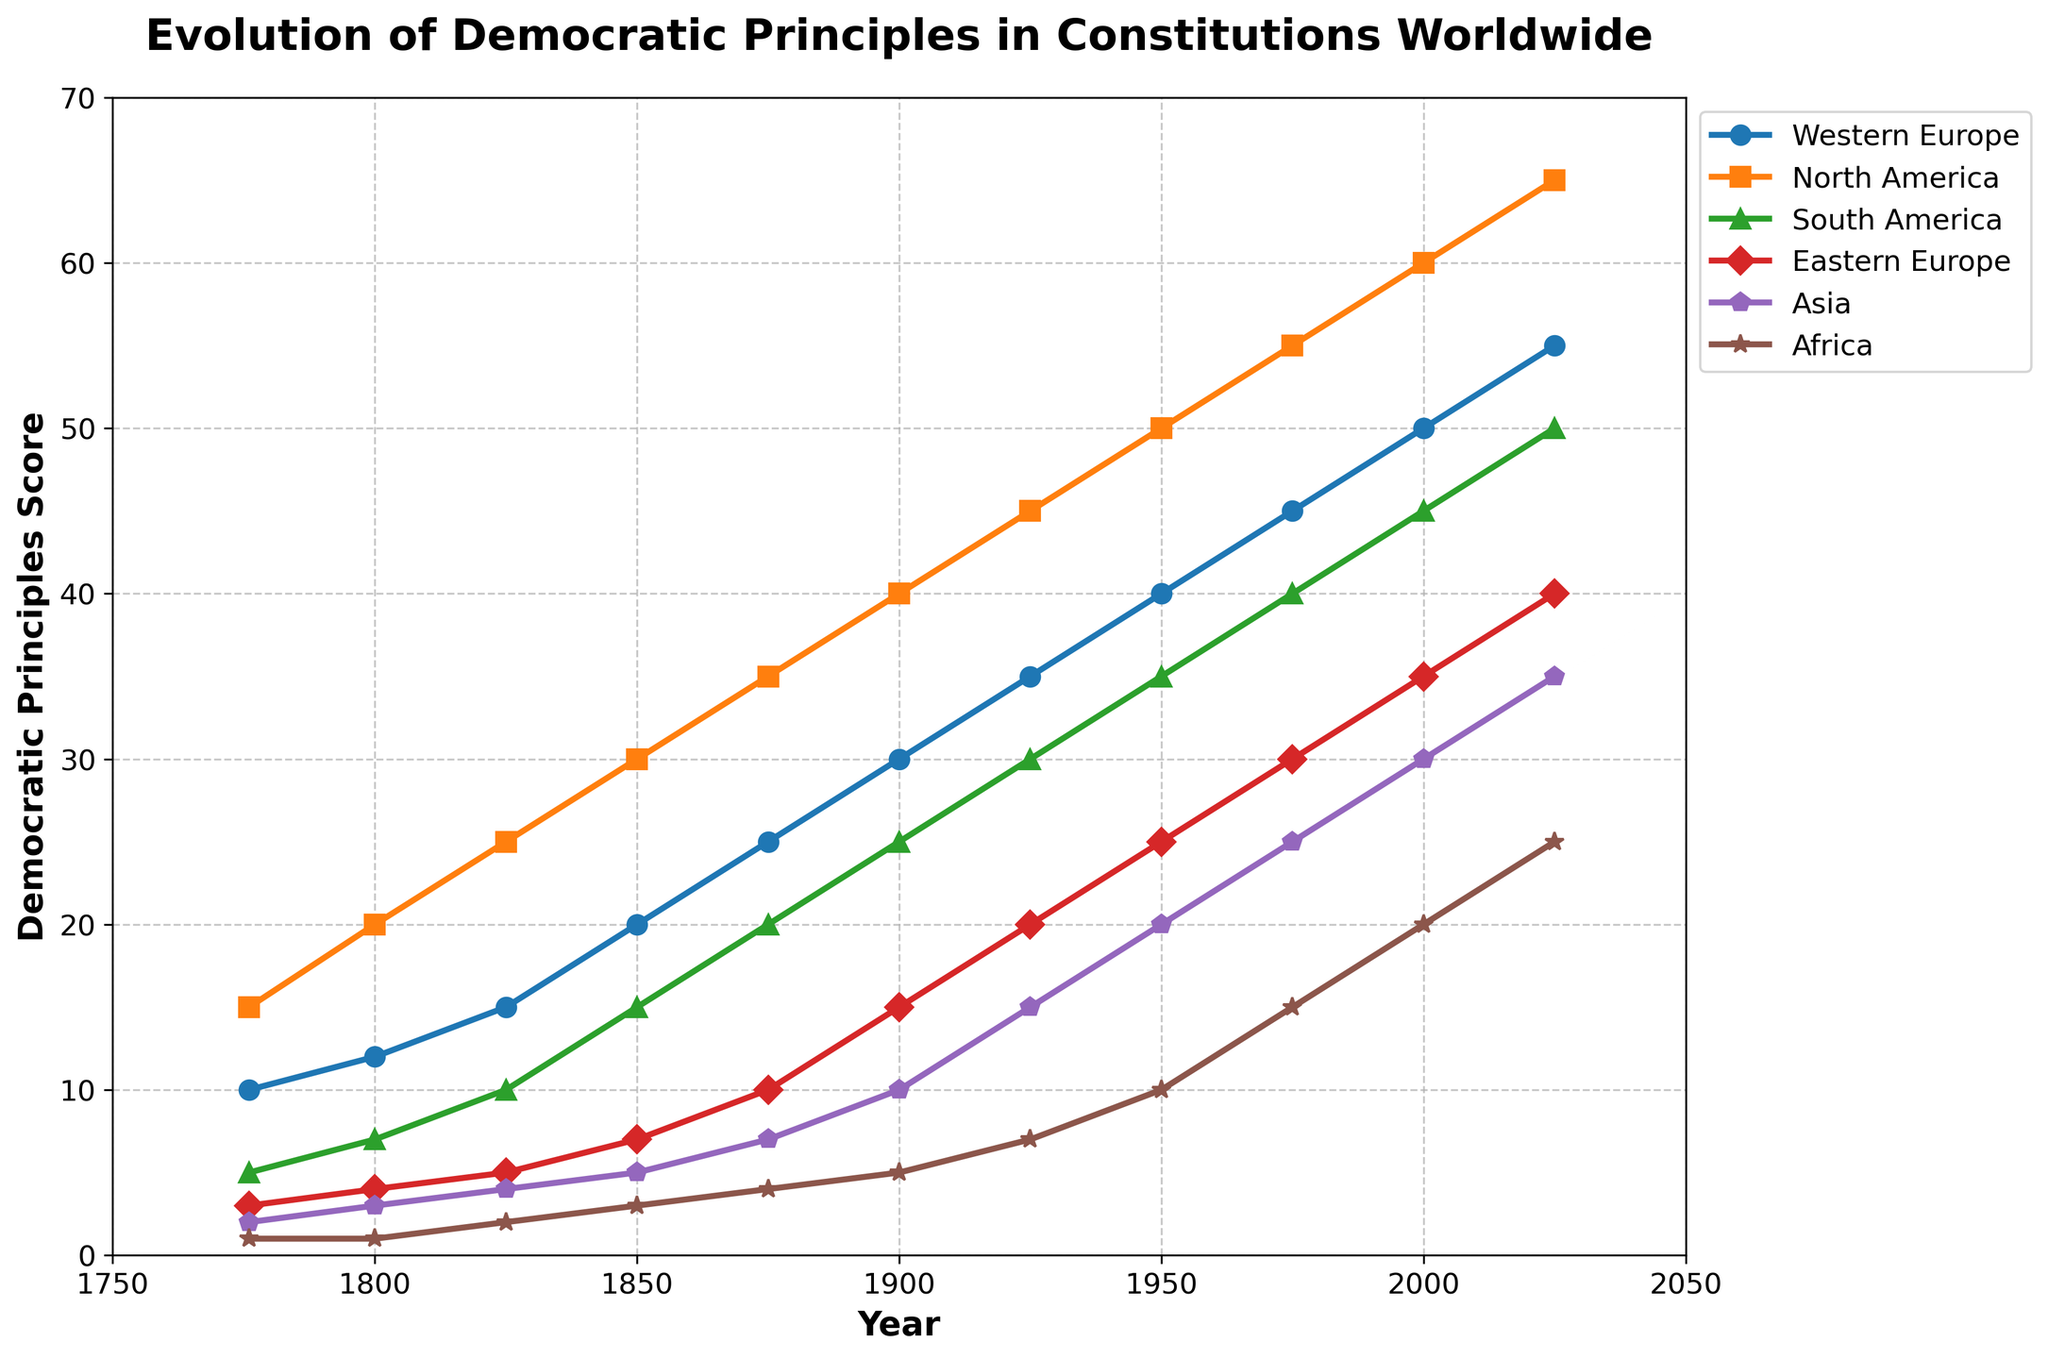What is the general trend of democratic principles in Western Europe from 1776 to 2025? To determine the general trend, observe the plotted line for Western Europe (marked with blue). The line shows an overall upward trajectory, indicating that the democratic principles score has increased from 10 in 1776 to 55 in 2025.
Answer: The trend is increasing Which region had the highest democratic principles score in 1900? Identify the scores for all regions in the year 1900 from the figure. The values are Western Europe (30), North America (40), South America (25), Eastern Europe (15), Asia (10), and Africa (5). North America has the highest score of 40.
Answer: North America By how much did the democratic principles score in South America increase from 1776 to 2025? Subtract the score in 1776 (5) from the score in 2025 (50). This gives 50 - 5 = 45, indicating an increase of 45.
Answer: 45 Which region shows the steepest increase in democratic principles between 1900 and 1950? Observe the slopes of the lines between 1900 and 1950 for each region. Calculate the increases: Western Europe (30 to 40 = 10), North America (40 to 50 = 10), South America (25 to 35 = 10), Eastern Europe (15 to 25 = 10), Asia (10 to 20 = 10), Africa (5 to 10 = 5). All regions except Africa had the same steep increase of 10, so focus on the gradient steepness visually for tie-breaking.
Answer: Equal steep increases in most regions except Africa Compare the democratic principles score of Asia to Africa in 2025 and determine the score difference. Find the scores for Asia and Africa in 2025: Asia (35), Africa (25). Subtract Africa's score from Asia’s (35 - 25), resulting in a difference of 10.
Answer: 10 Which decade saw the largest increase in democratic principles in North America? Compare the scores for North America at each plotted point and compute the increase decade by decade: 1776-1800 (5), 1800-1825 (5), 1825-1850 (5), 1850-1875 (5), 1875-1900 (5), 1900-1925 (5), 1925-1950 (5), 1950-1975 (5), 1975-2000 (5), 2000-2025 (5). The increases are the same, hence all decades saw equal increases.
Answer: Equal increases each decade Which region had the least number of increases in democratic principles? Identify the region with the smallest increase over the entire period. Check initial and final values: Western Europe (45), North America (50), South America (45), Eastern Europe (37), Asia (33), Africa (24). Africa had the smallest aggregate increase.
Answer: Africa 